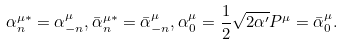Convert formula to latex. <formula><loc_0><loc_0><loc_500><loc_500>\alpha _ { n } ^ { \mu * } = \alpha _ { - n } ^ { \mu } , \bar { \alpha } _ { n } ^ { \mu * } = \bar { \alpha } _ { - n } ^ { \mu } , \alpha _ { 0 } ^ { \mu } = \frac { 1 } { 2 } \sqrt { 2 \alpha ^ { \prime } } P ^ { \mu } = \bar { \alpha } _ { 0 } ^ { \mu } .</formula> 